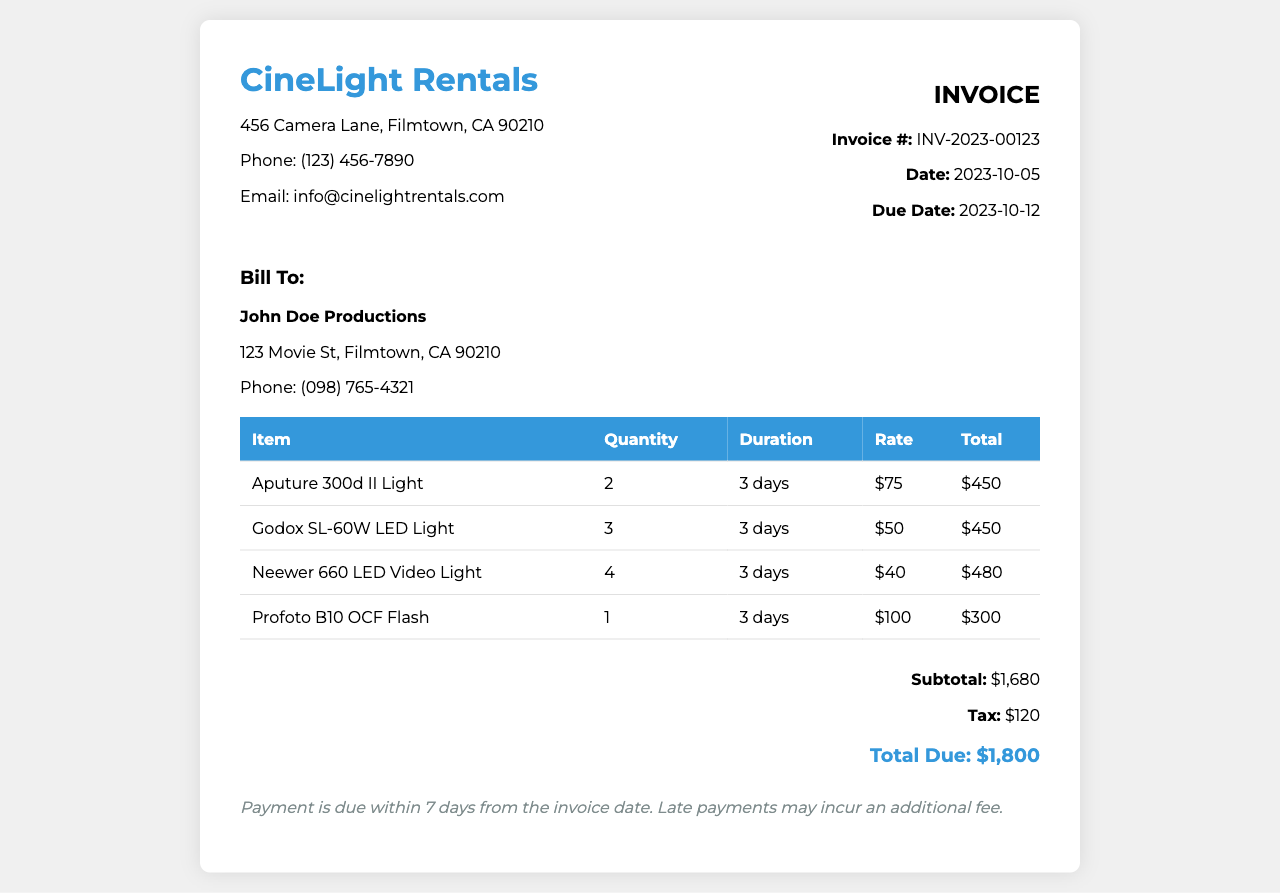What is the invoice number? The invoice number is clearly stated in the invoice information section.
Answer: INV-2023-00123 What is the due date for payment? The due date is listed under the invoice information section.
Answer: 2023-10-12 How many Aputure 300d II Lights were rented? The quantity rented is specified in the itemized list of lights.
Answer: 2 What is the total amount due? The total amount due can be found in the summary section of the invoice.
Answer: $1,800 What is the tax amount? The tax amount is listed in the summary section of the invoice.
Answer: $120 How long was the lighting equipment rented for? The duration for all items is mentioned consistently in the itemized section.
Answer: 3 days What is the rate for the Godox SL-60W LED Light? The rate is specified in the itemized list for the specific light.
Answer: $50 How many types of lights are listed in the invoice? The number of different lights can be counted from the itemized list provided.
Answer: 4 Who is the invoice billed to? The information about the recipient of the invoice is provided in the client info section.
Answer: John Doe Productions 